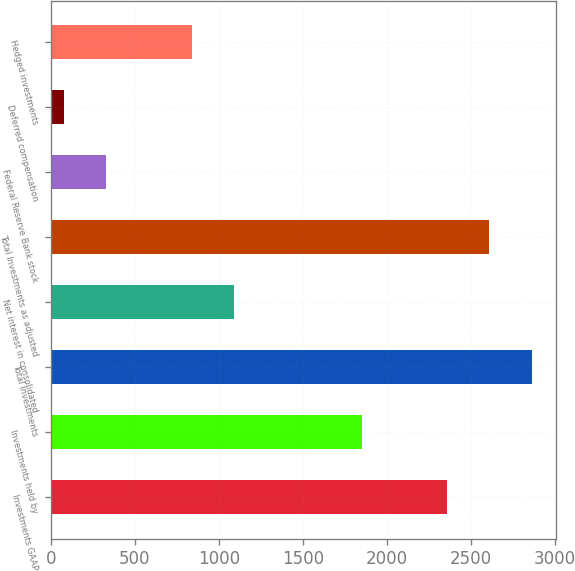Convert chart to OTSL. <chart><loc_0><loc_0><loc_500><loc_500><bar_chart><fcel>Investments GAAP<fcel>Investments held by<fcel>Total Investments<fcel>Net interest in consolidated<fcel>Total Investments as adjusted<fcel>Federal Reserve Bank stock<fcel>Deferred compensation<fcel>Hedged investments<nl><fcel>2355.1<fcel>1849.3<fcel>2860.9<fcel>1090.6<fcel>2608<fcel>331.9<fcel>79<fcel>837.7<nl></chart> 